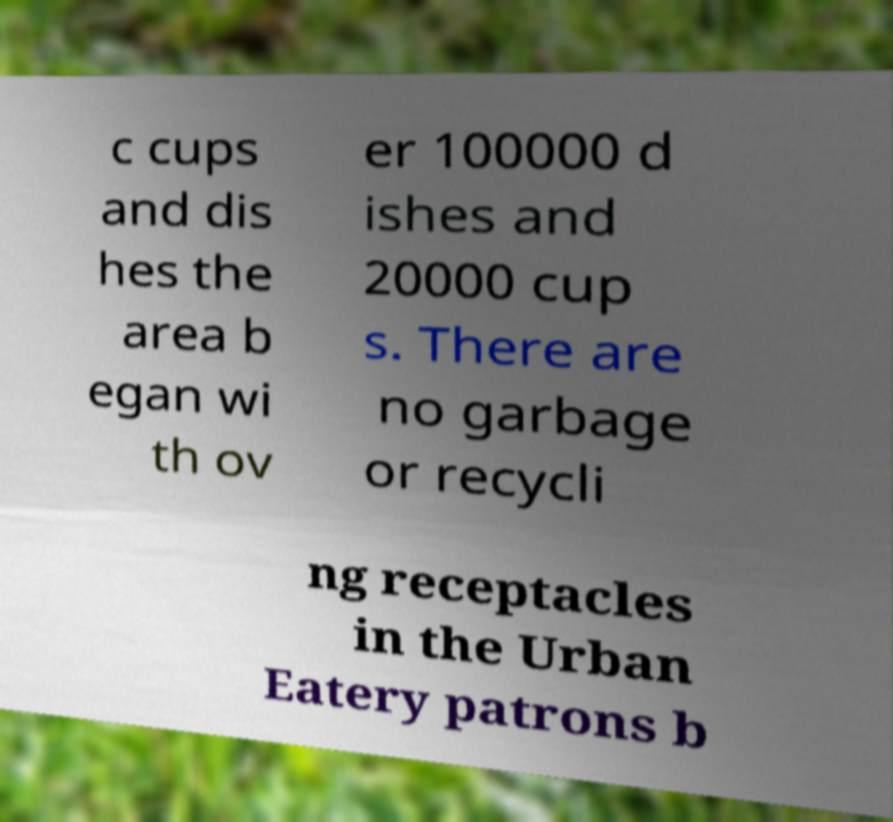For documentation purposes, I need the text within this image transcribed. Could you provide that? c cups and dis hes the area b egan wi th ov er 100000 d ishes and 20000 cup s. There are no garbage or recycli ng receptacles in the Urban Eatery patrons b 